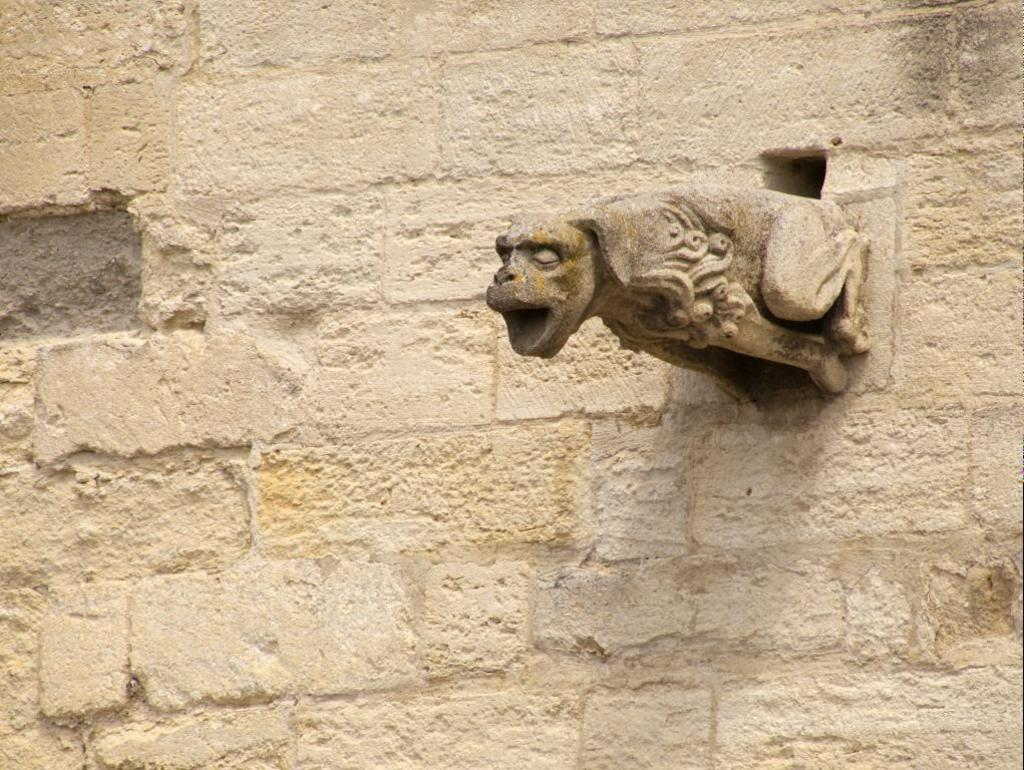What is the main subject of the image? The main subject of the image is a sculpture on the wall. Can you describe the sculpture in the image? Unfortunately, the provided facts do not include a description of the sculpture. What is the location of the sculpture in the image? The sculpture is on the wall in the image. What religious beliefs are represented by the sculpture in the image? There is no information about the sculpture's religious significance in the provided facts, so it cannot be determined from the image. 